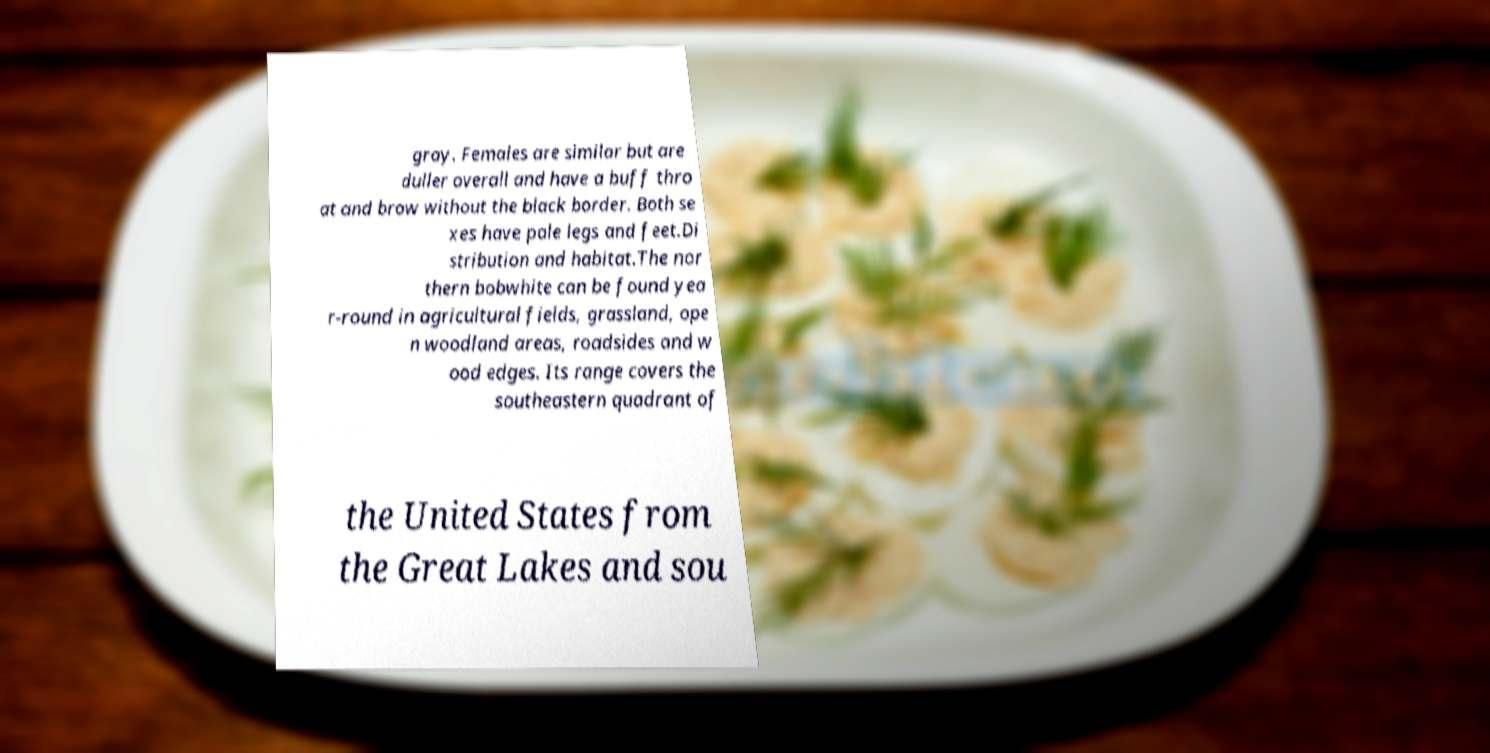There's text embedded in this image that I need extracted. Can you transcribe it verbatim? gray. Females are similar but are duller overall and have a buff thro at and brow without the black border. Both se xes have pale legs and feet.Di stribution and habitat.The nor thern bobwhite can be found yea r-round in agricultural fields, grassland, ope n woodland areas, roadsides and w ood edges. Its range covers the southeastern quadrant of the United States from the Great Lakes and sou 